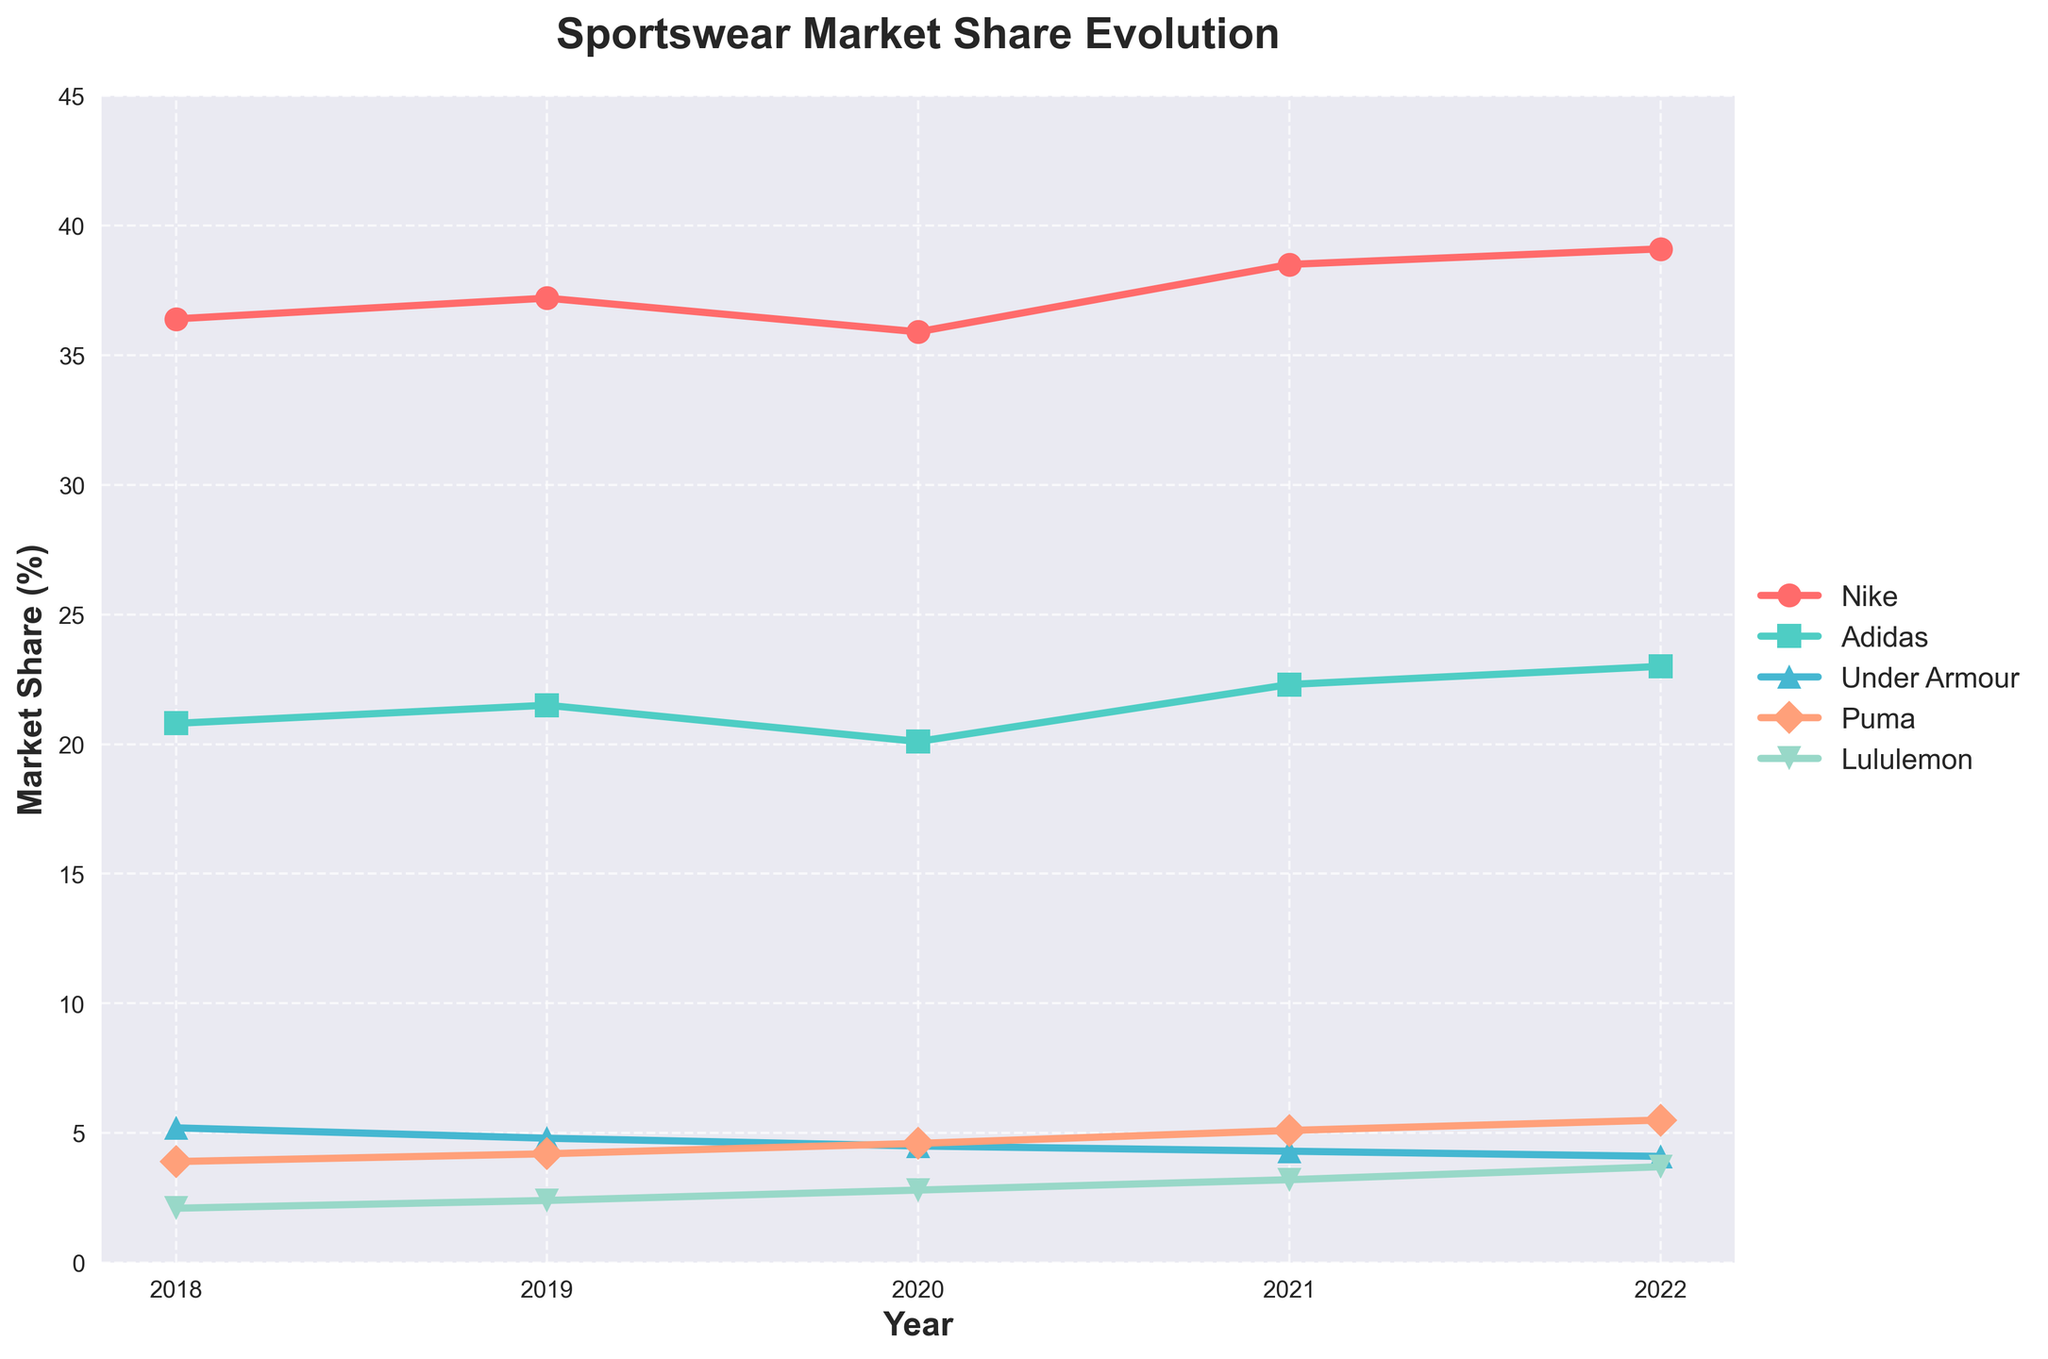What's the highest market share reached by Nike over the years? Look at the Nike line on the chart, and identify the highest point on the y-axis for Nike over the five years.
Answer: 39.1% Which brand had the lowest market share in 2018? Look at the values for each brand in 2018, and identify the lowest one.
Answer: Lululemon Between 2020 and 2022, which brand experienced the greatest increase in market share? Calculate the difference between 2022 and 2020 market shares for each brand, and compare to see which brand has the highest positive change.
Answer: Nike (+3.2%) Which two brands had a market share of around 4.5% in 2020? Look at the 2020 data points and find the brands with market shares close to 4.5%.
Answer: Under Armour, Puma How did Nike's market share change from 2018 to 2022? Subtract Nike's 2018 market share value from its 2022 value to determine the change.
Answer: +2.7% Which brand's market share remained closest to 4.5% across the five years? Observe the market share values for Puma and Under Armour and determine which stays around 4.5% across the years.
Answer: Under Armour Compare the market shares of Adidas and Nike in 2021. Which one is greater and by how much? Check the 2021 values for both Adidas and Nike and subtract Adidas's value from Nike's value.
Answer: Nike by 16.2% From 2018 to 2019, which brand saw the highest increase in their market share and how much was the increase? Calculate the difference between 2019 and 2018 values for each brand and identify the maximum.
Answer: Nike, 0.8% Which two brands have the most similar market shares in 2022? Compare the 2022 market share values and find the two closest values.
Answer: Puma and Lululemon What was the market share trend for Puma over the past five years? Observe the values for Puma from 2018 to 2022, and describe if they increase, decrease, or remain consistent.
Answer: Increasing 